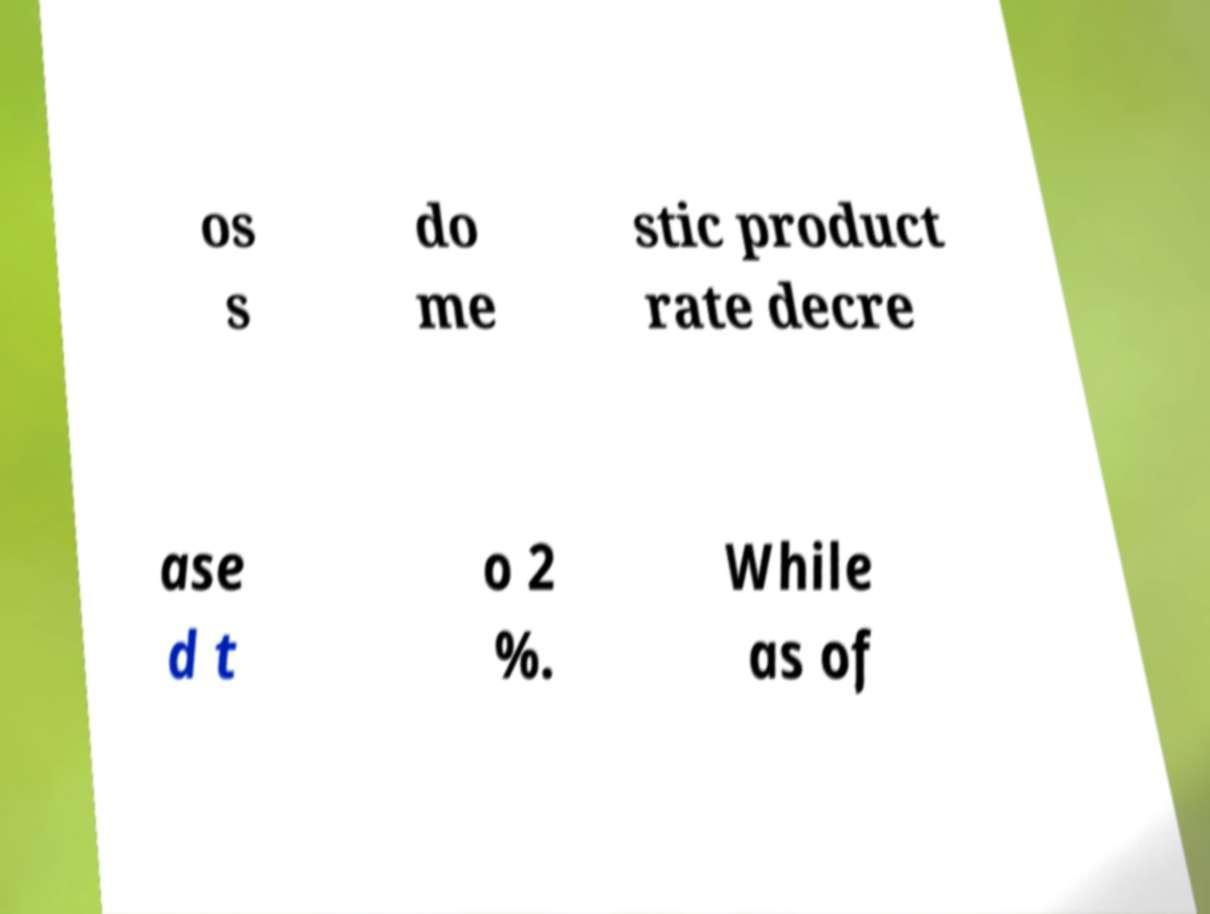For documentation purposes, I need the text within this image transcribed. Could you provide that? os s do me stic product rate decre ase d t o 2 %. While as of 